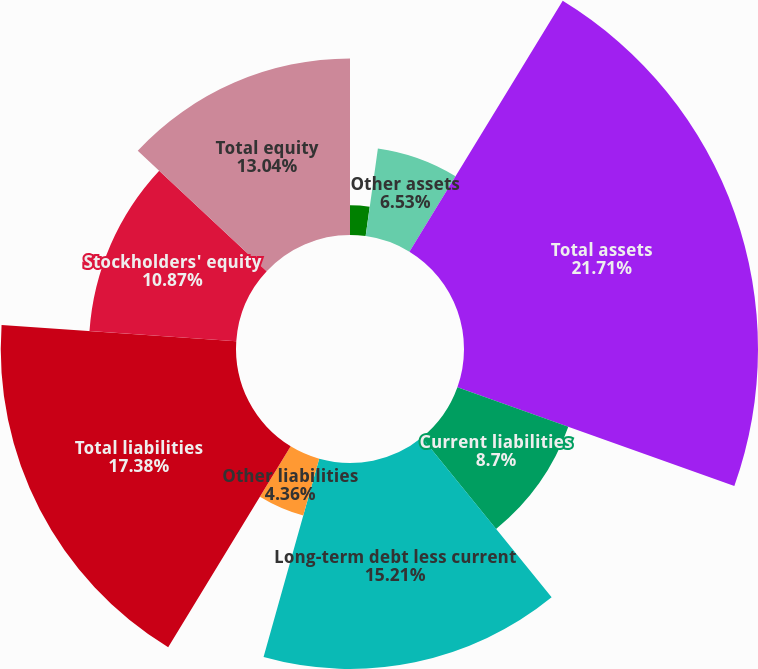<chart> <loc_0><loc_0><loc_500><loc_500><pie_chart><fcel>Current assets<fcel>Property plant equipment and<fcel>Other assets<fcel>Total assets<fcel>Current liabilities<fcel>Long-term debt less current<fcel>Other liabilities<fcel>Total liabilities<fcel>Stockholders' equity<fcel>Total equity<nl><fcel>2.19%<fcel>0.01%<fcel>6.53%<fcel>21.72%<fcel>8.7%<fcel>15.21%<fcel>4.36%<fcel>17.38%<fcel>10.87%<fcel>13.04%<nl></chart> 